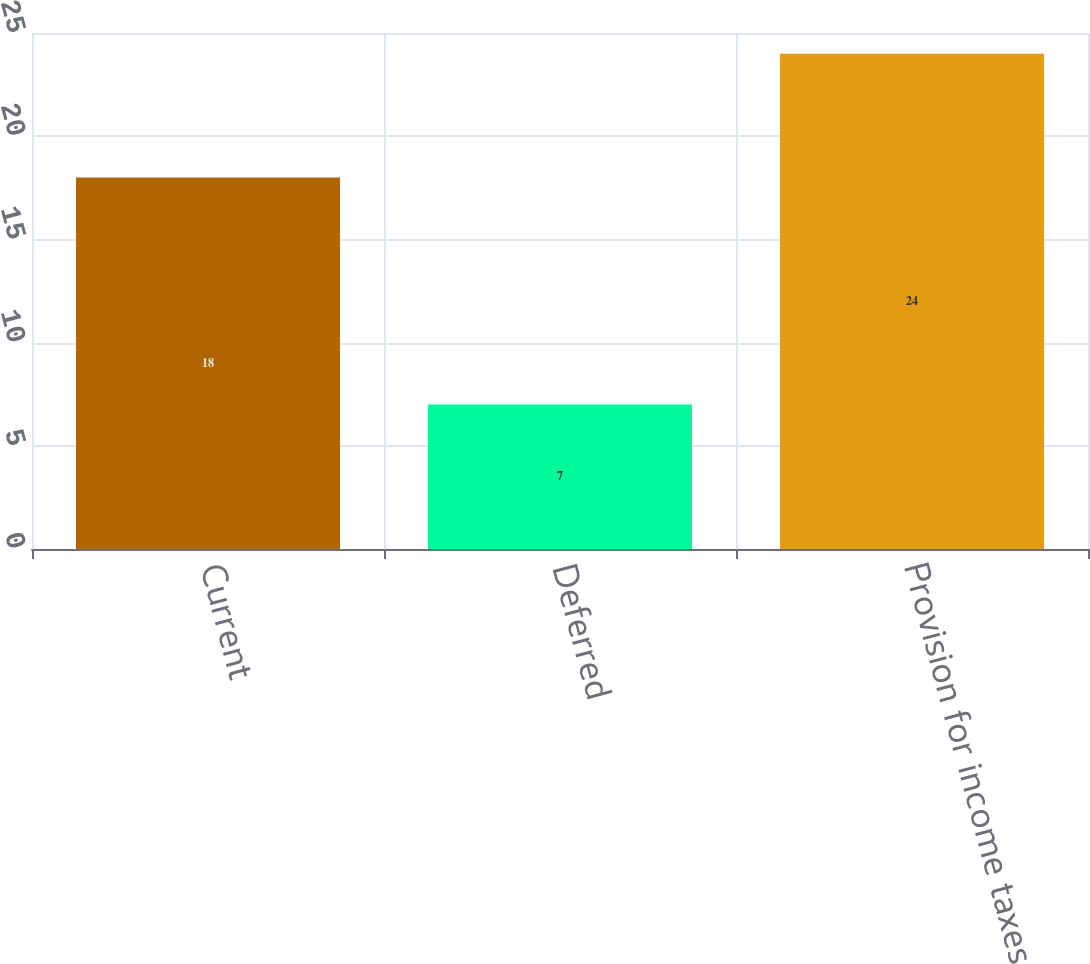Convert chart to OTSL. <chart><loc_0><loc_0><loc_500><loc_500><bar_chart><fcel>Current<fcel>Deferred<fcel>Provision for income taxes<nl><fcel>18<fcel>7<fcel>24<nl></chart> 